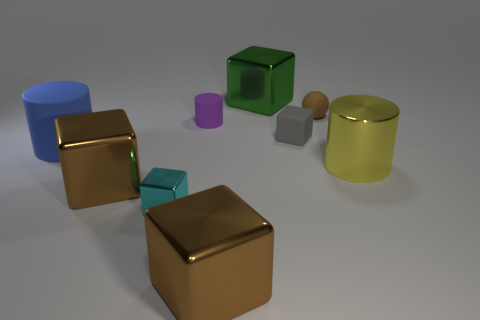Subtract all cyan metallic cubes. How many cubes are left? 4 Subtract 1 cubes. How many cubes are left? 4 Subtract all green cubes. How many cubes are left? 4 Subtract all yellow blocks. Subtract all green cylinders. How many blocks are left? 5 Add 1 tiny gray matte cylinders. How many objects exist? 10 Subtract all balls. How many objects are left? 8 Subtract all tiny brown rubber objects. Subtract all big green objects. How many objects are left? 7 Add 4 yellow objects. How many yellow objects are left? 5 Add 3 small objects. How many small objects exist? 7 Subtract 0 red cylinders. How many objects are left? 9 